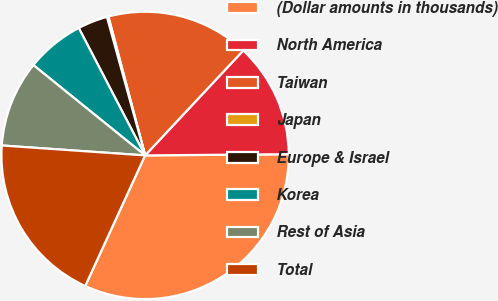Convert chart to OTSL. <chart><loc_0><loc_0><loc_500><loc_500><pie_chart><fcel>(Dollar amounts in thousands)<fcel>North America<fcel>Taiwan<fcel>Japan<fcel>Europe & Israel<fcel>Korea<fcel>Rest of Asia<fcel>Total<nl><fcel>31.98%<fcel>12.9%<fcel>16.08%<fcel>0.17%<fcel>3.36%<fcel>6.54%<fcel>9.72%<fcel>19.26%<nl></chart> 